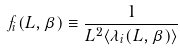<formula> <loc_0><loc_0><loc_500><loc_500>f _ { i } ( L , \beta ) \equiv \frac { 1 } { L ^ { 2 } \langle \lambda _ { i } ( L , \beta ) \rangle }</formula> 